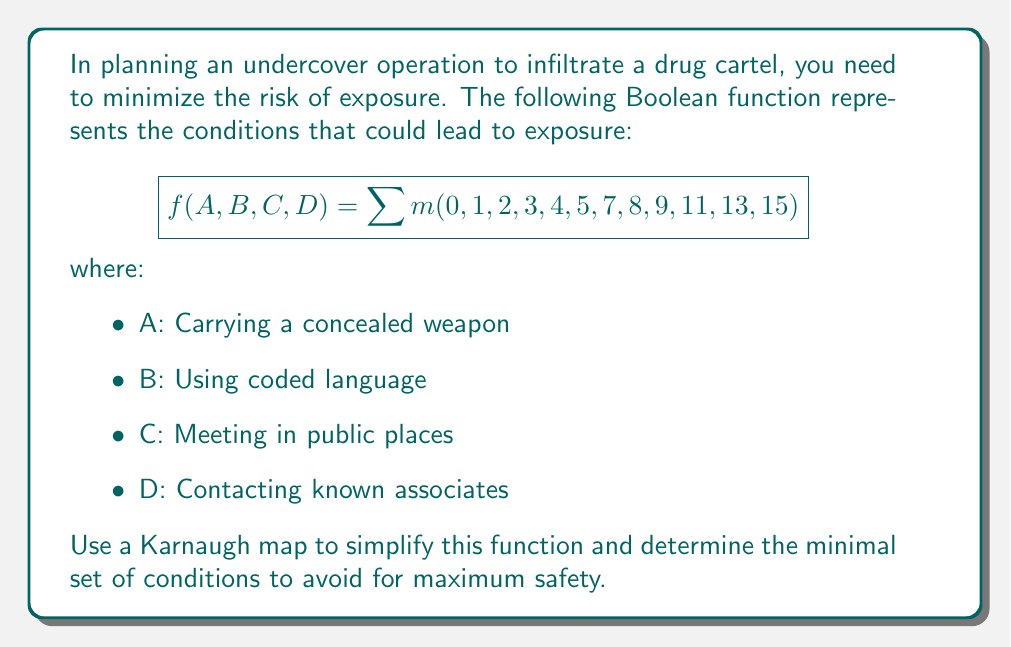Show me your answer to this math problem. Step 1: Create a 4-variable Karnaugh map:

[asy]
unitsize(1cm);
defaultpen(fontsize(10pt));

for(int i=0; i<4; ++i) {
  for(int j=0; j<4; ++j) {
    draw((i,j)--(i+1,j)--(i+1,j+1)--(i,j+1)--cycle);
  }
}

label("00", (0.5,-0.5));
label("01", (1.5,-0.5));
label("11", (2.5,-0.5));
label("10", (3.5,-0.5));

label("00", (-0.5,0.5));
label("01", (-0.5,1.5));
label("11", (-0.5,2.5));
label("10", (-0.5,3.5));

label("AB", (-0.5,-0.5));
label("CD", (-1,1.75));

label("1", (0.5,0.5));
label("1", (1.5,0.5));
label("1", (2.5,0.5));
label("1", (3.5,0.5));
label("1", (0.5,1.5));
label("1", (1.5,1.5));
label("1", (3.5,1.5));
label("1", (0.5,2.5));
label("1", (1.5,2.5));
label("1", (3.5,2.5));
label("1", (0.5,3.5));
label("1", (3.5,3.5));
[/asy]

Step 2: Identify the largest groups of 1s:
- Group 1: 8 cells in the left half (A')
- Group 2: 4 cells in the top right corner (CD)

Step 3: Write the simplified Boolean expression:
$f(A,B,C,D) = A' + CD$

Step 4: Interpret the result:
To minimize risk, avoid:
1. Not carrying a concealed weapon (A')
2. Meeting in public places AND contacting known associates (CD)

This simplified function represents the minimal set of conditions to avoid for maximum safety during the undercover operation.
Answer: $A' + CD$ 